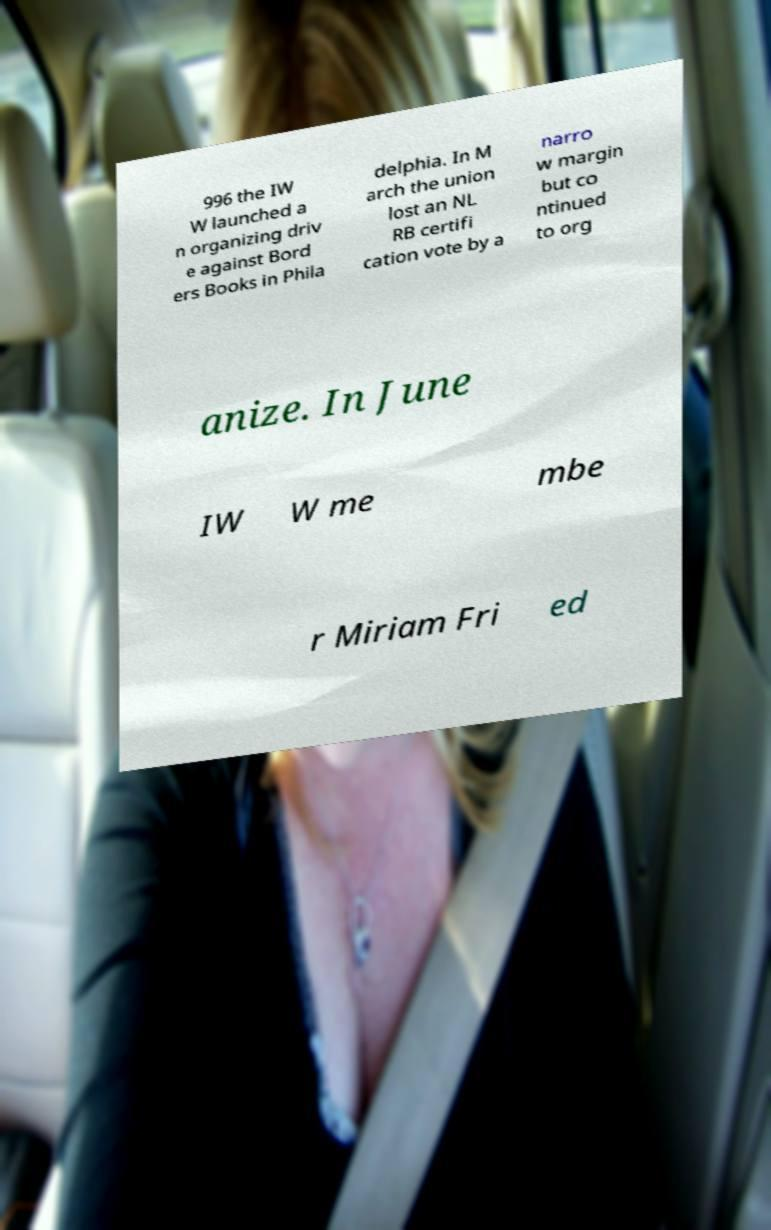I need the written content from this picture converted into text. Can you do that? 996 the IW W launched a n organizing driv e against Bord ers Books in Phila delphia. In M arch the union lost an NL RB certifi cation vote by a narro w margin but co ntinued to org anize. In June IW W me mbe r Miriam Fri ed 